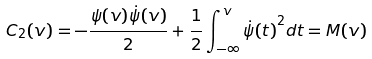Convert formula to latex. <formula><loc_0><loc_0><loc_500><loc_500>C _ { 2 } ( v ) = - \frac { \psi ( v ) \dot { \psi } ( v ) } { 2 } + \frac { 1 } { 2 } \int _ { - \infty } ^ { v } { \dot { \psi } ( t ) } ^ { 2 } d t = M ( v )</formula> 